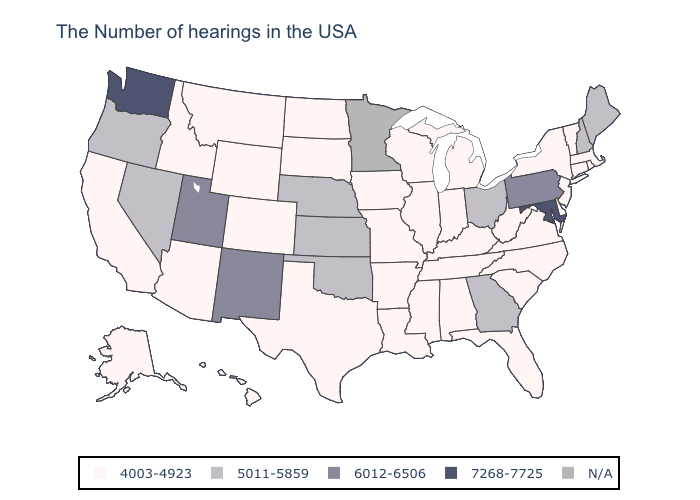What is the value of Maine?
Concise answer only. 5011-5859. Does Oklahoma have the lowest value in the South?
Give a very brief answer. No. What is the value of Maryland?
Keep it brief. 7268-7725. What is the highest value in the USA?
Answer briefly. 7268-7725. What is the value of Idaho?
Answer briefly. 4003-4923. What is the highest value in states that border Nevada?
Keep it brief. 6012-6506. How many symbols are there in the legend?
Keep it brief. 5. Name the states that have a value in the range N/A?
Be succinct. Minnesota. Name the states that have a value in the range N/A?
Short answer required. Minnesota. Which states hav the highest value in the South?
Short answer required. Maryland. What is the value of Illinois?
Keep it brief. 4003-4923. Which states hav the highest value in the Northeast?
Give a very brief answer. Pennsylvania. What is the value of Kansas?
Concise answer only. 5011-5859. 